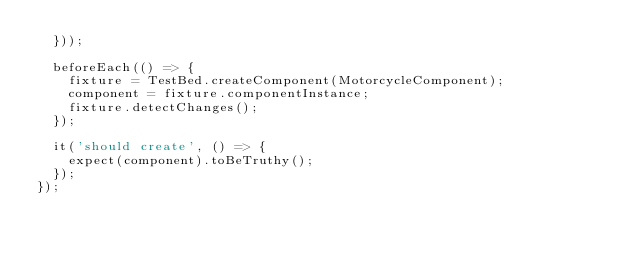<code> <loc_0><loc_0><loc_500><loc_500><_TypeScript_>  }));

  beforeEach(() => {
    fixture = TestBed.createComponent(MotorcycleComponent);
    component = fixture.componentInstance;
    fixture.detectChanges();
  });

  it('should create', () => {
    expect(component).toBeTruthy();
  });
});
</code> 